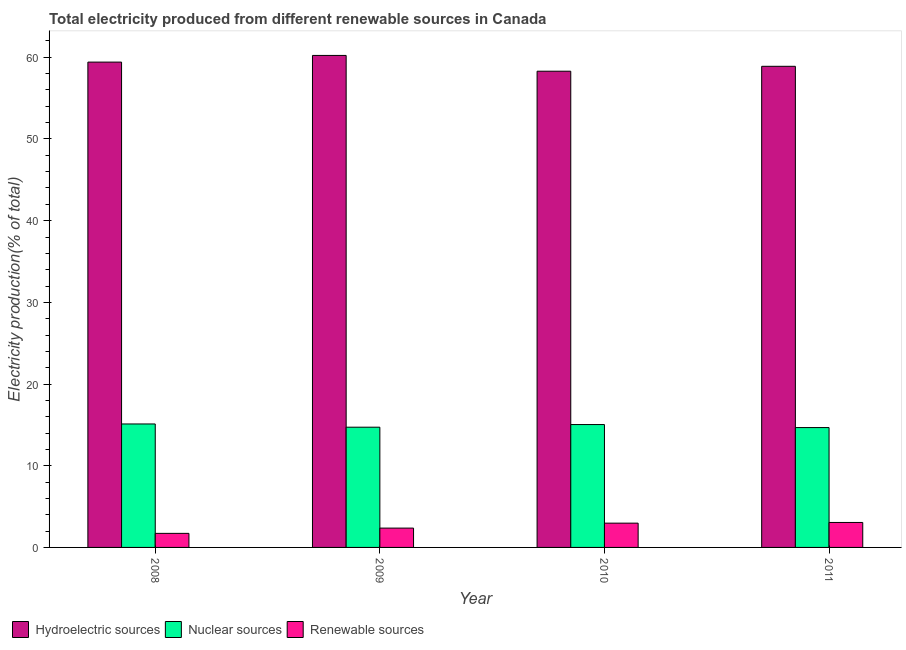How many bars are there on the 3rd tick from the left?
Give a very brief answer. 3. What is the percentage of electricity produced by nuclear sources in 2010?
Your answer should be very brief. 15.04. Across all years, what is the maximum percentage of electricity produced by hydroelectric sources?
Offer a very short reply. 60.23. Across all years, what is the minimum percentage of electricity produced by hydroelectric sources?
Ensure brevity in your answer.  58.29. In which year was the percentage of electricity produced by nuclear sources minimum?
Offer a terse response. 2011. What is the total percentage of electricity produced by hydroelectric sources in the graph?
Offer a very short reply. 236.83. What is the difference between the percentage of electricity produced by nuclear sources in 2009 and that in 2010?
Offer a very short reply. -0.32. What is the difference between the percentage of electricity produced by hydroelectric sources in 2010 and the percentage of electricity produced by nuclear sources in 2008?
Offer a very short reply. -1.12. What is the average percentage of electricity produced by renewable sources per year?
Your answer should be compact. 2.53. In how many years, is the percentage of electricity produced by renewable sources greater than 46 %?
Keep it short and to the point. 0. What is the ratio of the percentage of electricity produced by hydroelectric sources in 2009 to that in 2011?
Provide a short and direct response. 1.02. Is the percentage of electricity produced by renewable sources in 2008 less than that in 2010?
Your answer should be very brief. Yes. Is the difference between the percentage of electricity produced by hydroelectric sources in 2009 and 2011 greater than the difference between the percentage of electricity produced by nuclear sources in 2009 and 2011?
Offer a very short reply. No. What is the difference between the highest and the second highest percentage of electricity produced by nuclear sources?
Provide a short and direct response. 0.07. What is the difference between the highest and the lowest percentage of electricity produced by renewable sources?
Give a very brief answer. 1.34. In how many years, is the percentage of electricity produced by nuclear sources greater than the average percentage of electricity produced by nuclear sources taken over all years?
Offer a terse response. 2. Is the sum of the percentage of electricity produced by nuclear sources in 2010 and 2011 greater than the maximum percentage of electricity produced by renewable sources across all years?
Keep it short and to the point. Yes. What does the 2nd bar from the left in 2011 represents?
Give a very brief answer. Nuclear sources. What does the 1st bar from the right in 2008 represents?
Offer a terse response. Renewable sources. How many bars are there?
Keep it short and to the point. 12. How many years are there in the graph?
Your response must be concise. 4. What is the difference between two consecutive major ticks on the Y-axis?
Make the answer very short. 10. Does the graph contain any zero values?
Your answer should be compact. No. Does the graph contain grids?
Ensure brevity in your answer.  No. Where does the legend appear in the graph?
Make the answer very short. Bottom left. What is the title of the graph?
Your answer should be very brief. Total electricity produced from different renewable sources in Canada. What is the label or title of the Y-axis?
Offer a very short reply. Electricity production(% of total). What is the Electricity production(% of total) in Hydroelectric sources in 2008?
Offer a very short reply. 59.41. What is the Electricity production(% of total) in Nuclear sources in 2008?
Keep it short and to the point. 15.11. What is the Electricity production(% of total) in Renewable sources in 2008?
Give a very brief answer. 1.72. What is the Electricity production(% of total) in Hydroelectric sources in 2009?
Make the answer very short. 60.23. What is the Electricity production(% of total) of Nuclear sources in 2009?
Your response must be concise. 14.72. What is the Electricity production(% of total) in Renewable sources in 2009?
Offer a terse response. 2.37. What is the Electricity production(% of total) of Hydroelectric sources in 2010?
Your answer should be very brief. 58.29. What is the Electricity production(% of total) in Nuclear sources in 2010?
Make the answer very short. 15.04. What is the Electricity production(% of total) in Renewable sources in 2010?
Provide a short and direct response. 2.97. What is the Electricity production(% of total) in Hydroelectric sources in 2011?
Keep it short and to the point. 58.9. What is the Electricity production(% of total) in Nuclear sources in 2011?
Make the answer very short. 14.67. What is the Electricity production(% of total) of Renewable sources in 2011?
Offer a terse response. 3.06. Across all years, what is the maximum Electricity production(% of total) in Hydroelectric sources?
Your answer should be compact. 60.23. Across all years, what is the maximum Electricity production(% of total) in Nuclear sources?
Give a very brief answer. 15.11. Across all years, what is the maximum Electricity production(% of total) of Renewable sources?
Offer a very short reply. 3.06. Across all years, what is the minimum Electricity production(% of total) of Hydroelectric sources?
Provide a short and direct response. 58.29. Across all years, what is the minimum Electricity production(% of total) of Nuclear sources?
Ensure brevity in your answer.  14.67. Across all years, what is the minimum Electricity production(% of total) of Renewable sources?
Provide a short and direct response. 1.72. What is the total Electricity production(% of total) of Hydroelectric sources in the graph?
Ensure brevity in your answer.  236.83. What is the total Electricity production(% of total) of Nuclear sources in the graph?
Keep it short and to the point. 59.55. What is the total Electricity production(% of total) in Renewable sources in the graph?
Provide a short and direct response. 10.12. What is the difference between the Electricity production(% of total) of Hydroelectric sources in 2008 and that in 2009?
Your answer should be compact. -0.82. What is the difference between the Electricity production(% of total) of Nuclear sources in 2008 and that in 2009?
Make the answer very short. 0.39. What is the difference between the Electricity production(% of total) of Renewable sources in 2008 and that in 2009?
Provide a short and direct response. -0.64. What is the difference between the Electricity production(% of total) in Hydroelectric sources in 2008 and that in 2010?
Offer a terse response. 1.12. What is the difference between the Electricity production(% of total) of Nuclear sources in 2008 and that in 2010?
Keep it short and to the point. 0.07. What is the difference between the Electricity production(% of total) in Renewable sources in 2008 and that in 2010?
Ensure brevity in your answer.  -1.25. What is the difference between the Electricity production(% of total) in Hydroelectric sources in 2008 and that in 2011?
Your answer should be very brief. 0.51. What is the difference between the Electricity production(% of total) of Nuclear sources in 2008 and that in 2011?
Your answer should be very brief. 0.44. What is the difference between the Electricity production(% of total) in Renewable sources in 2008 and that in 2011?
Provide a succinct answer. -1.34. What is the difference between the Electricity production(% of total) in Hydroelectric sources in 2009 and that in 2010?
Provide a succinct answer. 1.93. What is the difference between the Electricity production(% of total) of Nuclear sources in 2009 and that in 2010?
Offer a very short reply. -0.32. What is the difference between the Electricity production(% of total) in Renewable sources in 2009 and that in 2010?
Give a very brief answer. -0.61. What is the difference between the Electricity production(% of total) in Hydroelectric sources in 2009 and that in 2011?
Provide a short and direct response. 1.33. What is the difference between the Electricity production(% of total) in Nuclear sources in 2009 and that in 2011?
Offer a very short reply. 0.05. What is the difference between the Electricity production(% of total) in Renewable sources in 2009 and that in 2011?
Your answer should be compact. -0.69. What is the difference between the Electricity production(% of total) in Hydroelectric sources in 2010 and that in 2011?
Your answer should be very brief. -0.6. What is the difference between the Electricity production(% of total) in Nuclear sources in 2010 and that in 2011?
Ensure brevity in your answer.  0.37. What is the difference between the Electricity production(% of total) in Renewable sources in 2010 and that in 2011?
Keep it short and to the point. -0.08. What is the difference between the Electricity production(% of total) of Hydroelectric sources in 2008 and the Electricity production(% of total) of Nuclear sources in 2009?
Provide a short and direct response. 44.69. What is the difference between the Electricity production(% of total) of Hydroelectric sources in 2008 and the Electricity production(% of total) of Renewable sources in 2009?
Make the answer very short. 57.04. What is the difference between the Electricity production(% of total) of Nuclear sources in 2008 and the Electricity production(% of total) of Renewable sources in 2009?
Ensure brevity in your answer.  12.75. What is the difference between the Electricity production(% of total) of Hydroelectric sources in 2008 and the Electricity production(% of total) of Nuclear sources in 2010?
Ensure brevity in your answer.  44.37. What is the difference between the Electricity production(% of total) of Hydroelectric sources in 2008 and the Electricity production(% of total) of Renewable sources in 2010?
Give a very brief answer. 56.44. What is the difference between the Electricity production(% of total) in Nuclear sources in 2008 and the Electricity production(% of total) in Renewable sources in 2010?
Your answer should be compact. 12.14. What is the difference between the Electricity production(% of total) in Hydroelectric sources in 2008 and the Electricity production(% of total) in Nuclear sources in 2011?
Your answer should be very brief. 44.74. What is the difference between the Electricity production(% of total) in Hydroelectric sources in 2008 and the Electricity production(% of total) in Renewable sources in 2011?
Provide a short and direct response. 56.35. What is the difference between the Electricity production(% of total) in Nuclear sources in 2008 and the Electricity production(% of total) in Renewable sources in 2011?
Your response must be concise. 12.06. What is the difference between the Electricity production(% of total) of Hydroelectric sources in 2009 and the Electricity production(% of total) of Nuclear sources in 2010?
Offer a very short reply. 45.19. What is the difference between the Electricity production(% of total) in Hydroelectric sources in 2009 and the Electricity production(% of total) in Renewable sources in 2010?
Offer a very short reply. 57.26. What is the difference between the Electricity production(% of total) in Nuclear sources in 2009 and the Electricity production(% of total) in Renewable sources in 2010?
Your answer should be very brief. 11.75. What is the difference between the Electricity production(% of total) of Hydroelectric sources in 2009 and the Electricity production(% of total) of Nuclear sources in 2011?
Your answer should be very brief. 45.56. What is the difference between the Electricity production(% of total) of Hydroelectric sources in 2009 and the Electricity production(% of total) of Renewable sources in 2011?
Provide a succinct answer. 57.17. What is the difference between the Electricity production(% of total) in Nuclear sources in 2009 and the Electricity production(% of total) in Renewable sources in 2011?
Your answer should be compact. 11.66. What is the difference between the Electricity production(% of total) in Hydroelectric sources in 2010 and the Electricity production(% of total) in Nuclear sources in 2011?
Offer a very short reply. 43.62. What is the difference between the Electricity production(% of total) of Hydroelectric sources in 2010 and the Electricity production(% of total) of Renewable sources in 2011?
Keep it short and to the point. 55.24. What is the difference between the Electricity production(% of total) in Nuclear sources in 2010 and the Electricity production(% of total) in Renewable sources in 2011?
Your answer should be compact. 11.98. What is the average Electricity production(% of total) in Hydroelectric sources per year?
Offer a terse response. 59.21. What is the average Electricity production(% of total) in Nuclear sources per year?
Your answer should be compact. 14.89. What is the average Electricity production(% of total) of Renewable sources per year?
Ensure brevity in your answer.  2.53. In the year 2008, what is the difference between the Electricity production(% of total) of Hydroelectric sources and Electricity production(% of total) of Nuclear sources?
Ensure brevity in your answer.  44.3. In the year 2008, what is the difference between the Electricity production(% of total) in Hydroelectric sources and Electricity production(% of total) in Renewable sources?
Give a very brief answer. 57.69. In the year 2008, what is the difference between the Electricity production(% of total) in Nuclear sources and Electricity production(% of total) in Renewable sources?
Offer a terse response. 13.39. In the year 2009, what is the difference between the Electricity production(% of total) of Hydroelectric sources and Electricity production(% of total) of Nuclear sources?
Offer a very short reply. 45.51. In the year 2009, what is the difference between the Electricity production(% of total) of Hydroelectric sources and Electricity production(% of total) of Renewable sources?
Your answer should be very brief. 57.86. In the year 2009, what is the difference between the Electricity production(% of total) of Nuclear sources and Electricity production(% of total) of Renewable sources?
Your answer should be very brief. 12.35. In the year 2010, what is the difference between the Electricity production(% of total) of Hydroelectric sources and Electricity production(% of total) of Nuclear sources?
Provide a succinct answer. 43.25. In the year 2010, what is the difference between the Electricity production(% of total) of Hydroelectric sources and Electricity production(% of total) of Renewable sources?
Your answer should be very brief. 55.32. In the year 2010, what is the difference between the Electricity production(% of total) in Nuclear sources and Electricity production(% of total) in Renewable sources?
Make the answer very short. 12.07. In the year 2011, what is the difference between the Electricity production(% of total) in Hydroelectric sources and Electricity production(% of total) in Nuclear sources?
Keep it short and to the point. 44.22. In the year 2011, what is the difference between the Electricity production(% of total) of Hydroelectric sources and Electricity production(% of total) of Renewable sources?
Your response must be concise. 55.84. In the year 2011, what is the difference between the Electricity production(% of total) in Nuclear sources and Electricity production(% of total) in Renewable sources?
Your response must be concise. 11.62. What is the ratio of the Electricity production(% of total) of Hydroelectric sources in 2008 to that in 2009?
Offer a terse response. 0.99. What is the ratio of the Electricity production(% of total) in Nuclear sources in 2008 to that in 2009?
Provide a short and direct response. 1.03. What is the ratio of the Electricity production(% of total) of Renewable sources in 2008 to that in 2009?
Make the answer very short. 0.73. What is the ratio of the Electricity production(% of total) in Hydroelectric sources in 2008 to that in 2010?
Your answer should be compact. 1.02. What is the ratio of the Electricity production(% of total) in Renewable sources in 2008 to that in 2010?
Make the answer very short. 0.58. What is the ratio of the Electricity production(% of total) of Hydroelectric sources in 2008 to that in 2011?
Provide a short and direct response. 1.01. What is the ratio of the Electricity production(% of total) of Nuclear sources in 2008 to that in 2011?
Your response must be concise. 1.03. What is the ratio of the Electricity production(% of total) in Renewable sources in 2008 to that in 2011?
Keep it short and to the point. 0.56. What is the ratio of the Electricity production(% of total) of Hydroelectric sources in 2009 to that in 2010?
Provide a succinct answer. 1.03. What is the ratio of the Electricity production(% of total) of Nuclear sources in 2009 to that in 2010?
Provide a short and direct response. 0.98. What is the ratio of the Electricity production(% of total) in Renewable sources in 2009 to that in 2010?
Your answer should be very brief. 0.8. What is the ratio of the Electricity production(% of total) of Hydroelectric sources in 2009 to that in 2011?
Offer a terse response. 1.02. What is the ratio of the Electricity production(% of total) of Nuclear sources in 2009 to that in 2011?
Keep it short and to the point. 1. What is the ratio of the Electricity production(% of total) of Renewable sources in 2009 to that in 2011?
Provide a short and direct response. 0.77. What is the ratio of the Electricity production(% of total) in Hydroelectric sources in 2010 to that in 2011?
Provide a short and direct response. 0.99. What is the ratio of the Electricity production(% of total) in Nuclear sources in 2010 to that in 2011?
Offer a terse response. 1.03. What is the ratio of the Electricity production(% of total) in Renewable sources in 2010 to that in 2011?
Your answer should be very brief. 0.97. What is the difference between the highest and the second highest Electricity production(% of total) of Hydroelectric sources?
Offer a terse response. 0.82. What is the difference between the highest and the second highest Electricity production(% of total) in Nuclear sources?
Offer a very short reply. 0.07. What is the difference between the highest and the second highest Electricity production(% of total) in Renewable sources?
Provide a succinct answer. 0.08. What is the difference between the highest and the lowest Electricity production(% of total) in Hydroelectric sources?
Your answer should be compact. 1.93. What is the difference between the highest and the lowest Electricity production(% of total) in Nuclear sources?
Keep it short and to the point. 0.44. What is the difference between the highest and the lowest Electricity production(% of total) of Renewable sources?
Give a very brief answer. 1.34. 